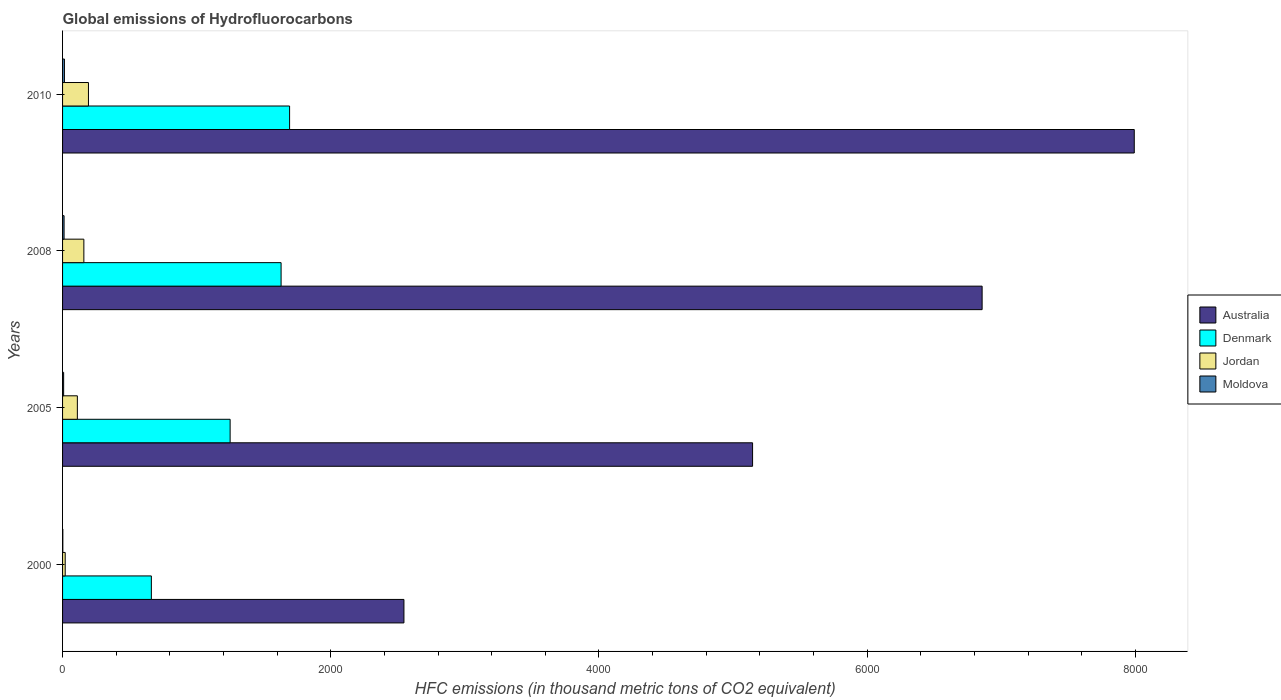How many different coloured bars are there?
Give a very brief answer. 4. How many groups of bars are there?
Offer a very short reply. 4. Are the number of bars per tick equal to the number of legend labels?
Make the answer very short. Yes. How many bars are there on the 4th tick from the top?
Offer a terse response. 4. How many bars are there on the 2nd tick from the bottom?
Offer a very short reply. 4. What is the label of the 4th group of bars from the top?
Provide a succinct answer. 2000. In how many cases, is the number of bars for a given year not equal to the number of legend labels?
Provide a succinct answer. 0. Across all years, what is the maximum global emissions of Hydrofluorocarbons in Moldova?
Provide a short and direct response. 14. What is the total global emissions of Hydrofluorocarbons in Jordan in the graph?
Keep it short and to the point. 481.8. What is the difference between the global emissions of Hydrofluorocarbons in Denmark in 2005 and that in 2010?
Provide a short and direct response. -443.5. What is the difference between the global emissions of Hydrofluorocarbons in Moldova in 2010 and the global emissions of Hydrofluorocarbons in Australia in 2005?
Give a very brief answer. -5131.6. What is the average global emissions of Hydrofluorocarbons in Jordan per year?
Your response must be concise. 120.45. In the year 2008, what is the difference between the global emissions of Hydrofluorocarbons in Moldova and global emissions of Hydrofluorocarbons in Australia?
Give a very brief answer. -6846.1. In how many years, is the global emissions of Hydrofluorocarbons in Australia greater than 6000 thousand metric tons?
Offer a terse response. 2. What is the ratio of the global emissions of Hydrofluorocarbons in Jordan in 2005 to that in 2010?
Your answer should be compact. 0.57. Is the difference between the global emissions of Hydrofluorocarbons in Moldova in 2005 and 2008 greater than the difference between the global emissions of Hydrofluorocarbons in Australia in 2005 and 2008?
Provide a short and direct response. Yes. What is the difference between the highest and the second highest global emissions of Hydrofluorocarbons in Jordan?
Make the answer very short. 34.2. What is the difference between the highest and the lowest global emissions of Hydrofluorocarbons in Moldova?
Give a very brief answer. 12.1. Is the sum of the global emissions of Hydrofluorocarbons in Moldova in 2008 and 2010 greater than the maximum global emissions of Hydrofluorocarbons in Denmark across all years?
Offer a very short reply. No. What does the 2nd bar from the top in 2010 represents?
Provide a short and direct response. Jordan. What does the 1st bar from the bottom in 2000 represents?
Provide a short and direct response. Australia. Is it the case that in every year, the sum of the global emissions of Hydrofluorocarbons in Denmark and global emissions of Hydrofluorocarbons in Jordan is greater than the global emissions of Hydrofluorocarbons in Moldova?
Provide a short and direct response. Yes. How many bars are there?
Your answer should be compact. 16. Are all the bars in the graph horizontal?
Give a very brief answer. Yes. How many years are there in the graph?
Give a very brief answer. 4. What is the difference between two consecutive major ticks on the X-axis?
Your answer should be very brief. 2000. Does the graph contain any zero values?
Provide a succinct answer. No. Does the graph contain grids?
Your answer should be compact. No. Where does the legend appear in the graph?
Your answer should be very brief. Center right. What is the title of the graph?
Ensure brevity in your answer.  Global emissions of Hydrofluorocarbons. Does "Heavily indebted poor countries" appear as one of the legend labels in the graph?
Provide a succinct answer. No. What is the label or title of the X-axis?
Offer a very short reply. HFC emissions (in thousand metric tons of CO2 equivalent). What is the label or title of the Y-axis?
Provide a short and direct response. Years. What is the HFC emissions (in thousand metric tons of CO2 equivalent) in Australia in 2000?
Provide a succinct answer. 2545.7. What is the HFC emissions (in thousand metric tons of CO2 equivalent) of Denmark in 2000?
Your response must be concise. 662.2. What is the HFC emissions (in thousand metric tons of CO2 equivalent) in Australia in 2005?
Provide a short and direct response. 5145.6. What is the HFC emissions (in thousand metric tons of CO2 equivalent) of Denmark in 2005?
Ensure brevity in your answer.  1249.5. What is the HFC emissions (in thousand metric tons of CO2 equivalent) in Jordan in 2005?
Your answer should be very brief. 110.3. What is the HFC emissions (in thousand metric tons of CO2 equivalent) in Australia in 2008?
Your response must be concise. 6857.4. What is the HFC emissions (in thousand metric tons of CO2 equivalent) of Denmark in 2008?
Offer a terse response. 1629.6. What is the HFC emissions (in thousand metric tons of CO2 equivalent) in Jordan in 2008?
Your answer should be compact. 158.8. What is the HFC emissions (in thousand metric tons of CO2 equivalent) in Australia in 2010?
Your answer should be very brief. 7992. What is the HFC emissions (in thousand metric tons of CO2 equivalent) in Denmark in 2010?
Give a very brief answer. 1693. What is the HFC emissions (in thousand metric tons of CO2 equivalent) in Jordan in 2010?
Ensure brevity in your answer.  193. Across all years, what is the maximum HFC emissions (in thousand metric tons of CO2 equivalent) in Australia?
Provide a succinct answer. 7992. Across all years, what is the maximum HFC emissions (in thousand metric tons of CO2 equivalent) of Denmark?
Ensure brevity in your answer.  1693. Across all years, what is the maximum HFC emissions (in thousand metric tons of CO2 equivalent) of Jordan?
Your response must be concise. 193. Across all years, what is the minimum HFC emissions (in thousand metric tons of CO2 equivalent) in Australia?
Ensure brevity in your answer.  2545.7. Across all years, what is the minimum HFC emissions (in thousand metric tons of CO2 equivalent) in Denmark?
Make the answer very short. 662.2. Across all years, what is the minimum HFC emissions (in thousand metric tons of CO2 equivalent) of Moldova?
Your answer should be compact. 1.9. What is the total HFC emissions (in thousand metric tons of CO2 equivalent) of Australia in the graph?
Offer a very short reply. 2.25e+04. What is the total HFC emissions (in thousand metric tons of CO2 equivalent) in Denmark in the graph?
Keep it short and to the point. 5234.3. What is the total HFC emissions (in thousand metric tons of CO2 equivalent) of Jordan in the graph?
Give a very brief answer. 481.8. What is the total HFC emissions (in thousand metric tons of CO2 equivalent) in Moldova in the graph?
Your response must be concise. 35.2. What is the difference between the HFC emissions (in thousand metric tons of CO2 equivalent) in Australia in 2000 and that in 2005?
Ensure brevity in your answer.  -2599.9. What is the difference between the HFC emissions (in thousand metric tons of CO2 equivalent) of Denmark in 2000 and that in 2005?
Provide a short and direct response. -587.3. What is the difference between the HFC emissions (in thousand metric tons of CO2 equivalent) in Jordan in 2000 and that in 2005?
Offer a terse response. -90.6. What is the difference between the HFC emissions (in thousand metric tons of CO2 equivalent) of Moldova in 2000 and that in 2005?
Ensure brevity in your answer.  -6.1. What is the difference between the HFC emissions (in thousand metric tons of CO2 equivalent) in Australia in 2000 and that in 2008?
Give a very brief answer. -4311.7. What is the difference between the HFC emissions (in thousand metric tons of CO2 equivalent) in Denmark in 2000 and that in 2008?
Your answer should be compact. -967.4. What is the difference between the HFC emissions (in thousand metric tons of CO2 equivalent) of Jordan in 2000 and that in 2008?
Offer a terse response. -139.1. What is the difference between the HFC emissions (in thousand metric tons of CO2 equivalent) in Moldova in 2000 and that in 2008?
Your answer should be very brief. -9.4. What is the difference between the HFC emissions (in thousand metric tons of CO2 equivalent) of Australia in 2000 and that in 2010?
Keep it short and to the point. -5446.3. What is the difference between the HFC emissions (in thousand metric tons of CO2 equivalent) in Denmark in 2000 and that in 2010?
Give a very brief answer. -1030.8. What is the difference between the HFC emissions (in thousand metric tons of CO2 equivalent) of Jordan in 2000 and that in 2010?
Your answer should be very brief. -173.3. What is the difference between the HFC emissions (in thousand metric tons of CO2 equivalent) of Moldova in 2000 and that in 2010?
Ensure brevity in your answer.  -12.1. What is the difference between the HFC emissions (in thousand metric tons of CO2 equivalent) of Australia in 2005 and that in 2008?
Give a very brief answer. -1711.8. What is the difference between the HFC emissions (in thousand metric tons of CO2 equivalent) in Denmark in 2005 and that in 2008?
Your answer should be very brief. -380.1. What is the difference between the HFC emissions (in thousand metric tons of CO2 equivalent) in Jordan in 2005 and that in 2008?
Offer a very short reply. -48.5. What is the difference between the HFC emissions (in thousand metric tons of CO2 equivalent) in Moldova in 2005 and that in 2008?
Provide a short and direct response. -3.3. What is the difference between the HFC emissions (in thousand metric tons of CO2 equivalent) in Australia in 2005 and that in 2010?
Ensure brevity in your answer.  -2846.4. What is the difference between the HFC emissions (in thousand metric tons of CO2 equivalent) in Denmark in 2005 and that in 2010?
Offer a terse response. -443.5. What is the difference between the HFC emissions (in thousand metric tons of CO2 equivalent) in Jordan in 2005 and that in 2010?
Provide a short and direct response. -82.7. What is the difference between the HFC emissions (in thousand metric tons of CO2 equivalent) of Australia in 2008 and that in 2010?
Provide a short and direct response. -1134.6. What is the difference between the HFC emissions (in thousand metric tons of CO2 equivalent) of Denmark in 2008 and that in 2010?
Make the answer very short. -63.4. What is the difference between the HFC emissions (in thousand metric tons of CO2 equivalent) in Jordan in 2008 and that in 2010?
Provide a short and direct response. -34.2. What is the difference between the HFC emissions (in thousand metric tons of CO2 equivalent) in Australia in 2000 and the HFC emissions (in thousand metric tons of CO2 equivalent) in Denmark in 2005?
Provide a succinct answer. 1296.2. What is the difference between the HFC emissions (in thousand metric tons of CO2 equivalent) of Australia in 2000 and the HFC emissions (in thousand metric tons of CO2 equivalent) of Jordan in 2005?
Provide a short and direct response. 2435.4. What is the difference between the HFC emissions (in thousand metric tons of CO2 equivalent) of Australia in 2000 and the HFC emissions (in thousand metric tons of CO2 equivalent) of Moldova in 2005?
Keep it short and to the point. 2537.7. What is the difference between the HFC emissions (in thousand metric tons of CO2 equivalent) of Denmark in 2000 and the HFC emissions (in thousand metric tons of CO2 equivalent) of Jordan in 2005?
Your response must be concise. 551.9. What is the difference between the HFC emissions (in thousand metric tons of CO2 equivalent) in Denmark in 2000 and the HFC emissions (in thousand metric tons of CO2 equivalent) in Moldova in 2005?
Keep it short and to the point. 654.2. What is the difference between the HFC emissions (in thousand metric tons of CO2 equivalent) of Jordan in 2000 and the HFC emissions (in thousand metric tons of CO2 equivalent) of Moldova in 2005?
Your answer should be very brief. 11.7. What is the difference between the HFC emissions (in thousand metric tons of CO2 equivalent) of Australia in 2000 and the HFC emissions (in thousand metric tons of CO2 equivalent) of Denmark in 2008?
Offer a very short reply. 916.1. What is the difference between the HFC emissions (in thousand metric tons of CO2 equivalent) of Australia in 2000 and the HFC emissions (in thousand metric tons of CO2 equivalent) of Jordan in 2008?
Keep it short and to the point. 2386.9. What is the difference between the HFC emissions (in thousand metric tons of CO2 equivalent) in Australia in 2000 and the HFC emissions (in thousand metric tons of CO2 equivalent) in Moldova in 2008?
Your answer should be very brief. 2534.4. What is the difference between the HFC emissions (in thousand metric tons of CO2 equivalent) of Denmark in 2000 and the HFC emissions (in thousand metric tons of CO2 equivalent) of Jordan in 2008?
Keep it short and to the point. 503.4. What is the difference between the HFC emissions (in thousand metric tons of CO2 equivalent) in Denmark in 2000 and the HFC emissions (in thousand metric tons of CO2 equivalent) in Moldova in 2008?
Provide a succinct answer. 650.9. What is the difference between the HFC emissions (in thousand metric tons of CO2 equivalent) of Jordan in 2000 and the HFC emissions (in thousand metric tons of CO2 equivalent) of Moldova in 2008?
Your answer should be very brief. 8.4. What is the difference between the HFC emissions (in thousand metric tons of CO2 equivalent) in Australia in 2000 and the HFC emissions (in thousand metric tons of CO2 equivalent) in Denmark in 2010?
Your response must be concise. 852.7. What is the difference between the HFC emissions (in thousand metric tons of CO2 equivalent) of Australia in 2000 and the HFC emissions (in thousand metric tons of CO2 equivalent) of Jordan in 2010?
Provide a short and direct response. 2352.7. What is the difference between the HFC emissions (in thousand metric tons of CO2 equivalent) of Australia in 2000 and the HFC emissions (in thousand metric tons of CO2 equivalent) of Moldova in 2010?
Offer a very short reply. 2531.7. What is the difference between the HFC emissions (in thousand metric tons of CO2 equivalent) in Denmark in 2000 and the HFC emissions (in thousand metric tons of CO2 equivalent) in Jordan in 2010?
Your answer should be very brief. 469.2. What is the difference between the HFC emissions (in thousand metric tons of CO2 equivalent) in Denmark in 2000 and the HFC emissions (in thousand metric tons of CO2 equivalent) in Moldova in 2010?
Offer a terse response. 648.2. What is the difference between the HFC emissions (in thousand metric tons of CO2 equivalent) of Jordan in 2000 and the HFC emissions (in thousand metric tons of CO2 equivalent) of Moldova in 2010?
Offer a very short reply. 5.7. What is the difference between the HFC emissions (in thousand metric tons of CO2 equivalent) of Australia in 2005 and the HFC emissions (in thousand metric tons of CO2 equivalent) of Denmark in 2008?
Ensure brevity in your answer.  3516. What is the difference between the HFC emissions (in thousand metric tons of CO2 equivalent) in Australia in 2005 and the HFC emissions (in thousand metric tons of CO2 equivalent) in Jordan in 2008?
Give a very brief answer. 4986.8. What is the difference between the HFC emissions (in thousand metric tons of CO2 equivalent) in Australia in 2005 and the HFC emissions (in thousand metric tons of CO2 equivalent) in Moldova in 2008?
Make the answer very short. 5134.3. What is the difference between the HFC emissions (in thousand metric tons of CO2 equivalent) of Denmark in 2005 and the HFC emissions (in thousand metric tons of CO2 equivalent) of Jordan in 2008?
Your answer should be very brief. 1090.7. What is the difference between the HFC emissions (in thousand metric tons of CO2 equivalent) of Denmark in 2005 and the HFC emissions (in thousand metric tons of CO2 equivalent) of Moldova in 2008?
Give a very brief answer. 1238.2. What is the difference between the HFC emissions (in thousand metric tons of CO2 equivalent) in Jordan in 2005 and the HFC emissions (in thousand metric tons of CO2 equivalent) in Moldova in 2008?
Ensure brevity in your answer.  99. What is the difference between the HFC emissions (in thousand metric tons of CO2 equivalent) in Australia in 2005 and the HFC emissions (in thousand metric tons of CO2 equivalent) in Denmark in 2010?
Ensure brevity in your answer.  3452.6. What is the difference between the HFC emissions (in thousand metric tons of CO2 equivalent) of Australia in 2005 and the HFC emissions (in thousand metric tons of CO2 equivalent) of Jordan in 2010?
Give a very brief answer. 4952.6. What is the difference between the HFC emissions (in thousand metric tons of CO2 equivalent) of Australia in 2005 and the HFC emissions (in thousand metric tons of CO2 equivalent) of Moldova in 2010?
Keep it short and to the point. 5131.6. What is the difference between the HFC emissions (in thousand metric tons of CO2 equivalent) of Denmark in 2005 and the HFC emissions (in thousand metric tons of CO2 equivalent) of Jordan in 2010?
Offer a very short reply. 1056.5. What is the difference between the HFC emissions (in thousand metric tons of CO2 equivalent) of Denmark in 2005 and the HFC emissions (in thousand metric tons of CO2 equivalent) of Moldova in 2010?
Your answer should be compact. 1235.5. What is the difference between the HFC emissions (in thousand metric tons of CO2 equivalent) of Jordan in 2005 and the HFC emissions (in thousand metric tons of CO2 equivalent) of Moldova in 2010?
Provide a succinct answer. 96.3. What is the difference between the HFC emissions (in thousand metric tons of CO2 equivalent) of Australia in 2008 and the HFC emissions (in thousand metric tons of CO2 equivalent) of Denmark in 2010?
Ensure brevity in your answer.  5164.4. What is the difference between the HFC emissions (in thousand metric tons of CO2 equivalent) in Australia in 2008 and the HFC emissions (in thousand metric tons of CO2 equivalent) in Jordan in 2010?
Give a very brief answer. 6664.4. What is the difference between the HFC emissions (in thousand metric tons of CO2 equivalent) of Australia in 2008 and the HFC emissions (in thousand metric tons of CO2 equivalent) of Moldova in 2010?
Your response must be concise. 6843.4. What is the difference between the HFC emissions (in thousand metric tons of CO2 equivalent) in Denmark in 2008 and the HFC emissions (in thousand metric tons of CO2 equivalent) in Jordan in 2010?
Offer a terse response. 1436.6. What is the difference between the HFC emissions (in thousand metric tons of CO2 equivalent) of Denmark in 2008 and the HFC emissions (in thousand metric tons of CO2 equivalent) of Moldova in 2010?
Keep it short and to the point. 1615.6. What is the difference between the HFC emissions (in thousand metric tons of CO2 equivalent) in Jordan in 2008 and the HFC emissions (in thousand metric tons of CO2 equivalent) in Moldova in 2010?
Provide a succinct answer. 144.8. What is the average HFC emissions (in thousand metric tons of CO2 equivalent) of Australia per year?
Give a very brief answer. 5635.18. What is the average HFC emissions (in thousand metric tons of CO2 equivalent) in Denmark per year?
Keep it short and to the point. 1308.58. What is the average HFC emissions (in thousand metric tons of CO2 equivalent) of Jordan per year?
Give a very brief answer. 120.45. In the year 2000, what is the difference between the HFC emissions (in thousand metric tons of CO2 equivalent) in Australia and HFC emissions (in thousand metric tons of CO2 equivalent) in Denmark?
Your response must be concise. 1883.5. In the year 2000, what is the difference between the HFC emissions (in thousand metric tons of CO2 equivalent) of Australia and HFC emissions (in thousand metric tons of CO2 equivalent) of Jordan?
Offer a very short reply. 2526. In the year 2000, what is the difference between the HFC emissions (in thousand metric tons of CO2 equivalent) in Australia and HFC emissions (in thousand metric tons of CO2 equivalent) in Moldova?
Provide a short and direct response. 2543.8. In the year 2000, what is the difference between the HFC emissions (in thousand metric tons of CO2 equivalent) of Denmark and HFC emissions (in thousand metric tons of CO2 equivalent) of Jordan?
Your answer should be very brief. 642.5. In the year 2000, what is the difference between the HFC emissions (in thousand metric tons of CO2 equivalent) in Denmark and HFC emissions (in thousand metric tons of CO2 equivalent) in Moldova?
Make the answer very short. 660.3. In the year 2005, what is the difference between the HFC emissions (in thousand metric tons of CO2 equivalent) of Australia and HFC emissions (in thousand metric tons of CO2 equivalent) of Denmark?
Provide a succinct answer. 3896.1. In the year 2005, what is the difference between the HFC emissions (in thousand metric tons of CO2 equivalent) in Australia and HFC emissions (in thousand metric tons of CO2 equivalent) in Jordan?
Your response must be concise. 5035.3. In the year 2005, what is the difference between the HFC emissions (in thousand metric tons of CO2 equivalent) of Australia and HFC emissions (in thousand metric tons of CO2 equivalent) of Moldova?
Your answer should be compact. 5137.6. In the year 2005, what is the difference between the HFC emissions (in thousand metric tons of CO2 equivalent) of Denmark and HFC emissions (in thousand metric tons of CO2 equivalent) of Jordan?
Keep it short and to the point. 1139.2. In the year 2005, what is the difference between the HFC emissions (in thousand metric tons of CO2 equivalent) in Denmark and HFC emissions (in thousand metric tons of CO2 equivalent) in Moldova?
Your response must be concise. 1241.5. In the year 2005, what is the difference between the HFC emissions (in thousand metric tons of CO2 equivalent) in Jordan and HFC emissions (in thousand metric tons of CO2 equivalent) in Moldova?
Offer a terse response. 102.3. In the year 2008, what is the difference between the HFC emissions (in thousand metric tons of CO2 equivalent) in Australia and HFC emissions (in thousand metric tons of CO2 equivalent) in Denmark?
Your response must be concise. 5227.8. In the year 2008, what is the difference between the HFC emissions (in thousand metric tons of CO2 equivalent) in Australia and HFC emissions (in thousand metric tons of CO2 equivalent) in Jordan?
Give a very brief answer. 6698.6. In the year 2008, what is the difference between the HFC emissions (in thousand metric tons of CO2 equivalent) in Australia and HFC emissions (in thousand metric tons of CO2 equivalent) in Moldova?
Ensure brevity in your answer.  6846.1. In the year 2008, what is the difference between the HFC emissions (in thousand metric tons of CO2 equivalent) of Denmark and HFC emissions (in thousand metric tons of CO2 equivalent) of Jordan?
Make the answer very short. 1470.8. In the year 2008, what is the difference between the HFC emissions (in thousand metric tons of CO2 equivalent) in Denmark and HFC emissions (in thousand metric tons of CO2 equivalent) in Moldova?
Keep it short and to the point. 1618.3. In the year 2008, what is the difference between the HFC emissions (in thousand metric tons of CO2 equivalent) of Jordan and HFC emissions (in thousand metric tons of CO2 equivalent) of Moldova?
Your response must be concise. 147.5. In the year 2010, what is the difference between the HFC emissions (in thousand metric tons of CO2 equivalent) of Australia and HFC emissions (in thousand metric tons of CO2 equivalent) of Denmark?
Provide a succinct answer. 6299. In the year 2010, what is the difference between the HFC emissions (in thousand metric tons of CO2 equivalent) of Australia and HFC emissions (in thousand metric tons of CO2 equivalent) of Jordan?
Ensure brevity in your answer.  7799. In the year 2010, what is the difference between the HFC emissions (in thousand metric tons of CO2 equivalent) in Australia and HFC emissions (in thousand metric tons of CO2 equivalent) in Moldova?
Provide a short and direct response. 7978. In the year 2010, what is the difference between the HFC emissions (in thousand metric tons of CO2 equivalent) in Denmark and HFC emissions (in thousand metric tons of CO2 equivalent) in Jordan?
Your answer should be very brief. 1500. In the year 2010, what is the difference between the HFC emissions (in thousand metric tons of CO2 equivalent) of Denmark and HFC emissions (in thousand metric tons of CO2 equivalent) of Moldova?
Keep it short and to the point. 1679. In the year 2010, what is the difference between the HFC emissions (in thousand metric tons of CO2 equivalent) in Jordan and HFC emissions (in thousand metric tons of CO2 equivalent) in Moldova?
Provide a succinct answer. 179. What is the ratio of the HFC emissions (in thousand metric tons of CO2 equivalent) of Australia in 2000 to that in 2005?
Ensure brevity in your answer.  0.49. What is the ratio of the HFC emissions (in thousand metric tons of CO2 equivalent) in Denmark in 2000 to that in 2005?
Keep it short and to the point. 0.53. What is the ratio of the HFC emissions (in thousand metric tons of CO2 equivalent) of Jordan in 2000 to that in 2005?
Your answer should be very brief. 0.18. What is the ratio of the HFC emissions (in thousand metric tons of CO2 equivalent) of Moldova in 2000 to that in 2005?
Offer a terse response. 0.24. What is the ratio of the HFC emissions (in thousand metric tons of CO2 equivalent) in Australia in 2000 to that in 2008?
Your answer should be very brief. 0.37. What is the ratio of the HFC emissions (in thousand metric tons of CO2 equivalent) of Denmark in 2000 to that in 2008?
Provide a short and direct response. 0.41. What is the ratio of the HFC emissions (in thousand metric tons of CO2 equivalent) of Jordan in 2000 to that in 2008?
Provide a short and direct response. 0.12. What is the ratio of the HFC emissions (in thousand metric tons of CO2 equivalent) in Moldova in 2000 to that in 2008?
Provide a short and direct response. 0.17. What is the ratio of the HFC emissions (in thousand metric tons of CO2 equivalent) in Australia in 2000 to that in 2010?
Provide a succinct answer. 0.32. What is the ratio of the HFC emissions (in thousand metric tons of CO2 equivalent) in Denmark in 2000 to that in 2010?
Ensure brevity in your answer.  0.39. What is the ratio of the HFC emissions (in thousand metric tons of CO2 equivalent) of Jordan in 2000 to that in 2010?
Make the answer very short. 0.1. What is the ratio of the HFC emissions (in thousand metric tons of CO2 equivalent) in Moldova in 2000 to that in 2010?
Your answer should be compact. 0.14. What is the ratio of the HFC emissions (in thousand metric tons of CO2 equivalent) of Australia in 2005 to that in 2008?
Offer a very short reply. 0.75. What is the ratio of the HFC emissions (in thousand metric tons of CO2 equivalent) in Denmark in 2005 to that in 2008?
Offer a terse response. 0.77. What is the ratio of the HFC emissions (in thousand metric tons of CO2 equivalent) in Jordan in 2005 to that in 2008?
Provide a succinct answer. 0.69. What is the ratio of the HFC emissions (in thousand metric tons of CO2 equivalent) in Moldova in 2005 to that in 2008?
Ensure brevity in your answer.  0.71. What is the ratio of the HFC emissions (in thousand metric tons of CO2 equivalent) of Australia in 2005 to that in 2010?
Your answer should be very brief. 0.64. What is the ratio of the HFC emissions (in thousand metric tons of CO2 equivalent) of Denmark in 2005 to that in 2010?
Offer a very short reply. 0.74. What is the ratio of the HFC emissions (in thousand metric tons of CO2 equivalent) of Jordan in 2005 to that in 2010?
Your answer should be compact. 0.57. What is the ratio of the HFC emissions (in thousand metric tons of CO2 equivalent) in Moldova in 2005 to that in 2010?
Keep it short and to the point. 0.57. What is the ratio of the HFC emissions (in thousand metric tons of CO2 equivalent) of Australia in 2008 to that in 2010?
Your answer should be compact. 0.86. What is the ratio of the HFC emissions (in thousand metric tons of CO2 equivalent) in Denmark in 2008 to that in 2010?
Give a very brief answer. 0.96. What is the ratio of the HFC emissions (in thousand metric tons of CO2 equivalent) of Jordan in 2008 to that in 2010?
Ensure brevity in your answer.  0.82. What is the ratio of the HFC emissions (in thousand metric tons of CO2 equivalent) in Moldova in 2008 to that in 2010?
Offer a very short reply. 0.81. What is the difference between the highest and the second highest HFC emissions (in thousand metric tons of CO2 equivalent) in Australia?
Offer a terse response. 1134.6. What is the difference between the highest and the second highest HFC emissions (in thousand metric tons of CO2 equivalent) in Denmark?
Give a very brief answer. 63.4. What is the difference between the highest and the second highest HFC emissions (in thousand metric tons of CO2 equivalent) of Jordan?
Offer a very short reply. 34.2. What is the difference between the highest and the lowest HFC emissions (in thousand metric tons of CO2 equivalent) in Australia?
Offer a very short reply. 5446.3. What is the difference between the highest and the lowest HFC emissions (in thousand metric tons of CO2 equivalent) in Denmark?
Keep it short and to the point. 1030.8. What is the difference between the highest and the lowest HFC emissions (in thousand metric tons of CO2 equivalent) of Jordan?
Ensure brevity in your answer.  173.3. What is the difference between the highest and the lowest HFC emissions (in thousand metric tons of CO2 equivalent) in Moldova?
Make the answer very short. 12.1. 